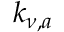<formula> <loc_0><loc_0><loc_500><loc_500>k _ { \nu , a }</formula> 